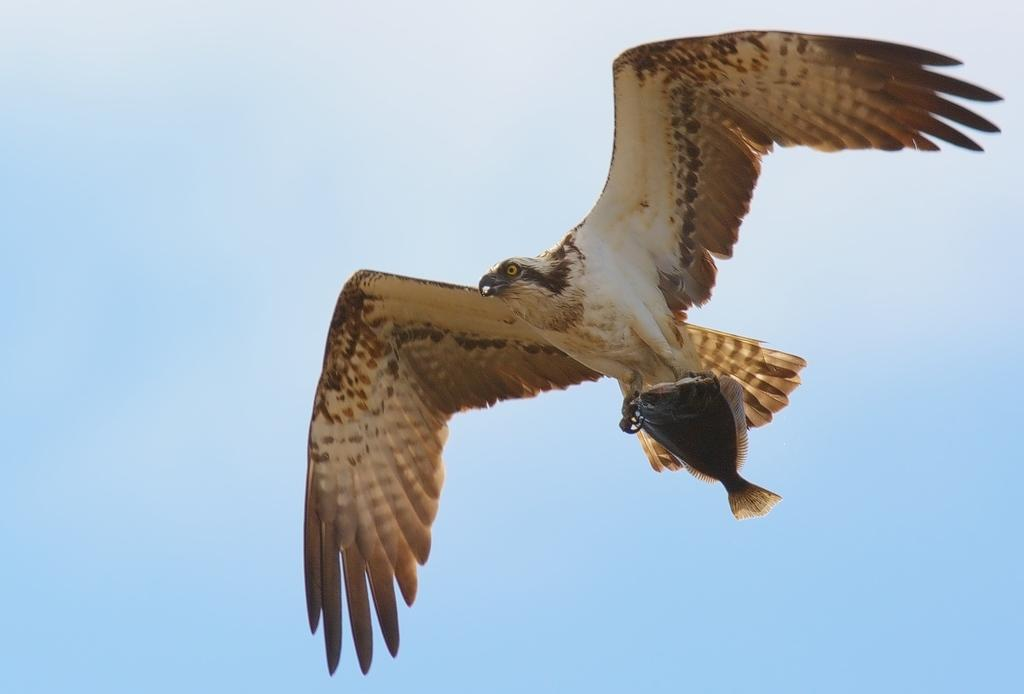What type of animal can be seen in the picture? There is a bird in the picture. What is the bird doing with its legs? The bird is holding a fish with its legs. Where is the bird located in the image? The bird is flying in the sky. What is the condition of the sky in the image? The sky is clear in the image. What type of slope can be seen in the image? There is no slope present in the image; it features a bird flying in the sky while holding a fish. Can you tell me the name of the minister in the image? There is no minister present in the image; it features a bird holding a fish while flying in the sky. 